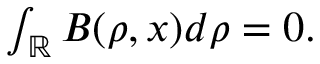<formula> <loc_0><loc_0><loc_500><loc_500>\begin{array} { r } { \int _ { \mathbb { R } } B ( \rho , x ) d \rho = 0 . } \end{array}</formula> 